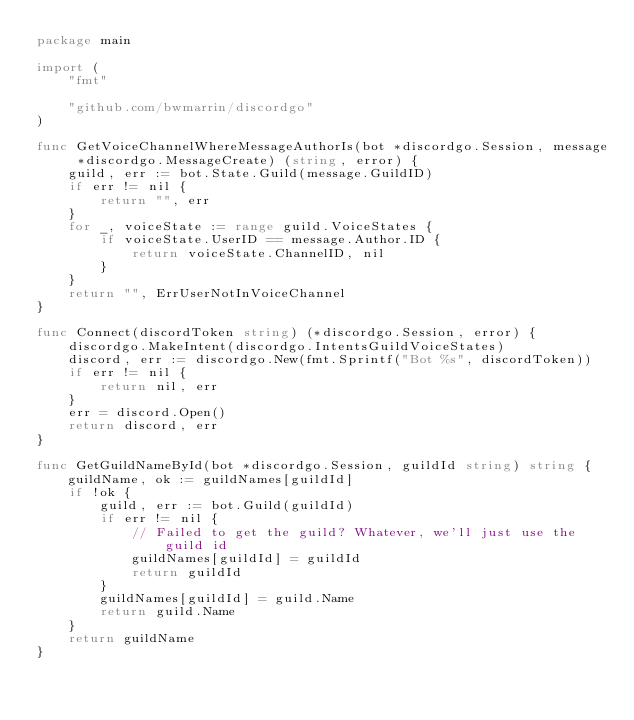Convert code to text. <code><loc_0><loc_0><loc_500><loc_500><_Go_>package main

import (
	"fmt"

	"github.com/bwmarrin/discordgo"
)

func GetVoiceChannelWhereMessageAuthorIs(bot *discordgo.Session, message *discordgo.MessageCreate) (string, error) {
	guild, err := bot.State.Guild(message.GuildID)
	if err != nil {
		return "", err
	}
	for _, voiceState := range guild.VoiceStates {
		if voiceState.UserID == message.Author.ID {
			return voiceState.ChannelID, nil
		}
	}
	return "", ErrUserNotInVoiceChannel
}

func Connect(discordToken string) (*discordgo.Session, error) {
	discordgo.MakeIntent(discordgo.IntentsGuildVoiceStates)
	discord, err := discordgo.New(fmt.Sprintf("Bot %s", discordToken))
	if err != nil {
		return nil, err
	}
	err = discord.Open()
	return discord, err
}

func GetGuildNameById(bot *discordgo.Session, guildId string) string {
	guildName, ok := guildNames[guildId]
	if !ok {
		guild, err := bot.Guild(guildId)
		if err != nil {
			// Failed to get the guild? Whatever, we'll just use the guild id
			guildNames[guildId] = guildId
			return guildId
		}
		guildNames[guildId] = guild.Name
		return guild.Name
	}
	return guildName
}
</code> 